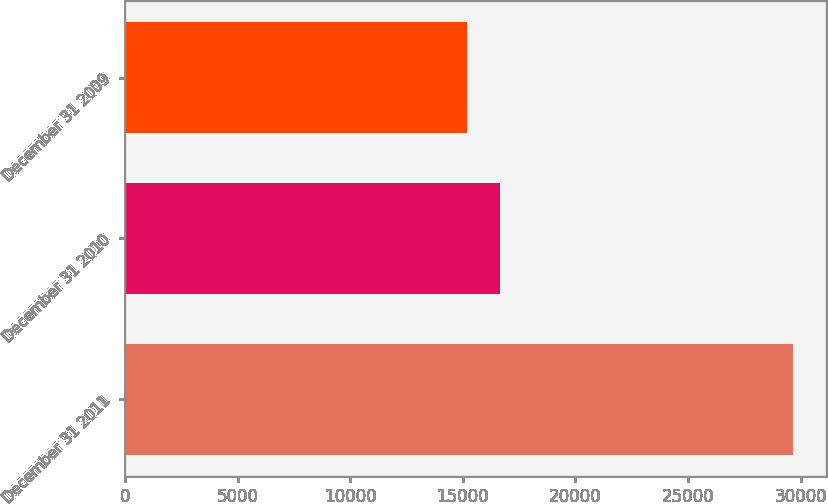Convert chart. <chart><loc_0><loc_0><loc_500><loc_500><bar_chart><fcel>December 31 2011<fcel>December 31 2010<fcel>December 31 2009<nl><fcel>29650<fcel>16651.3<fcel>15207<nl></chart> 